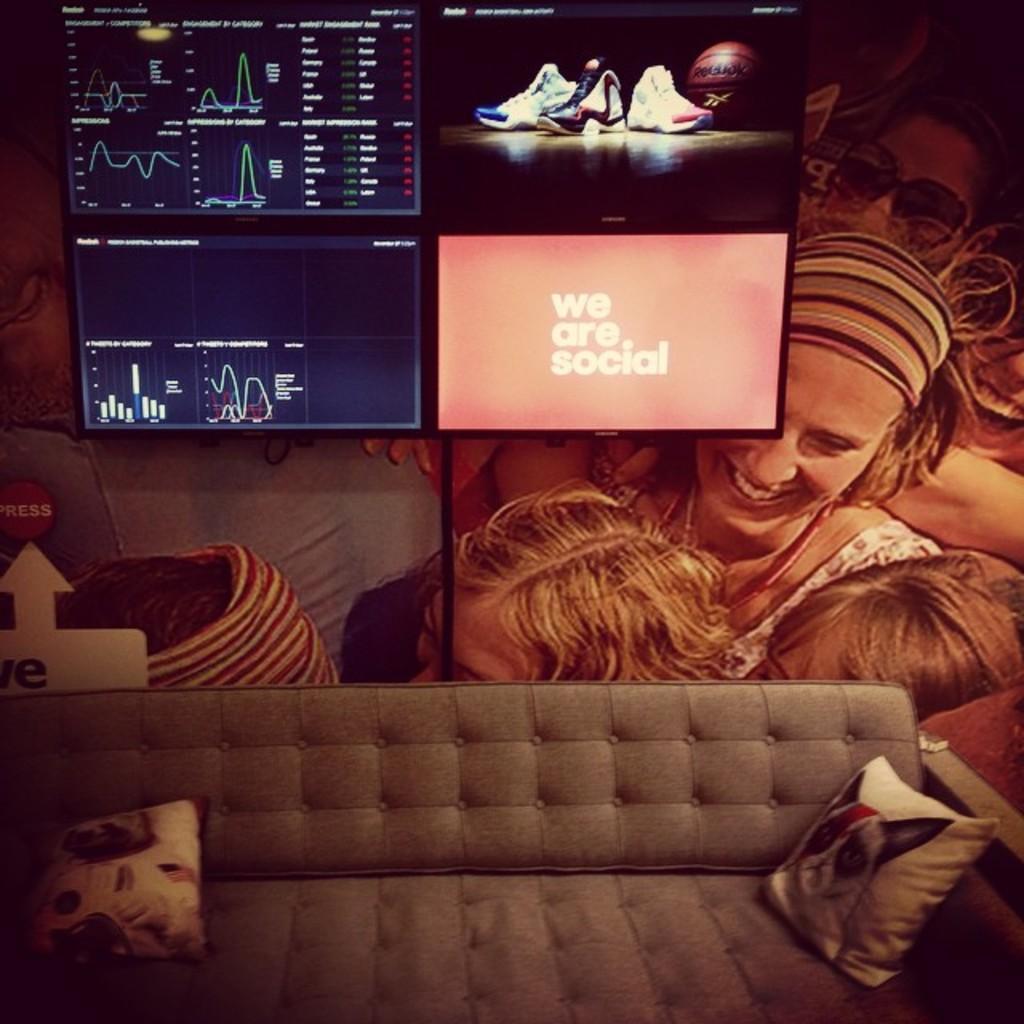Please provide a concise description of this image. In this picture we can see two women sitting and here we have sofa two pillows on it and we can see a screen where shoes, ball on it and this is a poster. 